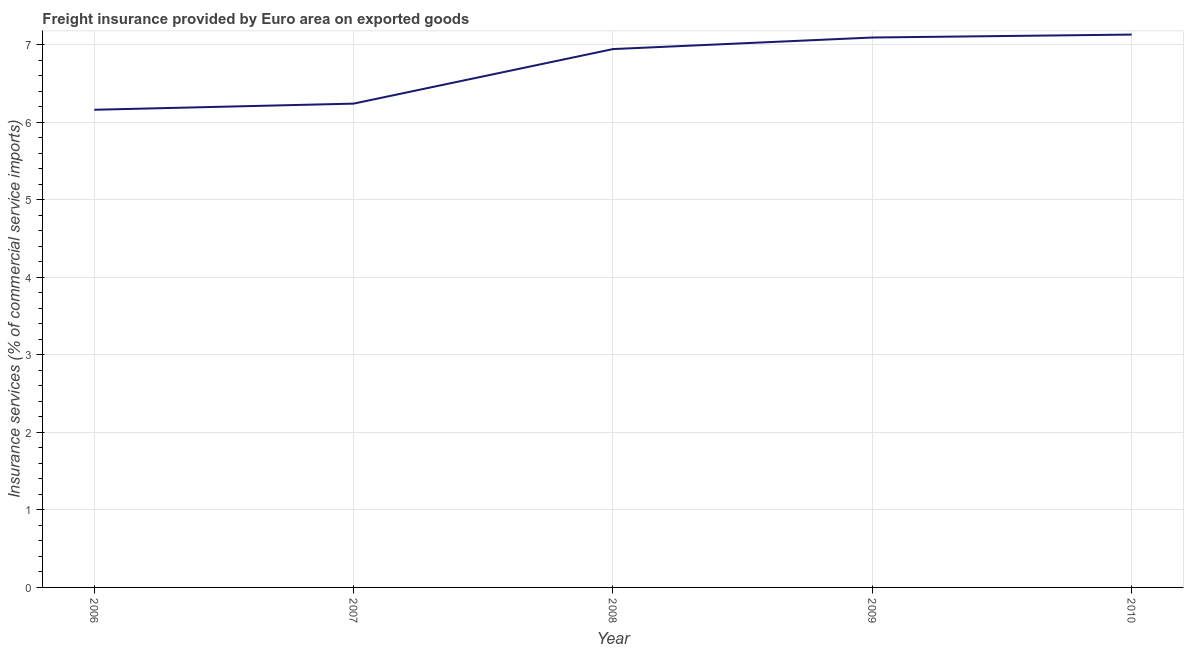What is the freight insurance in 2008?
Ensure brevity in your answer.  6.95. Across all years, what is the maximum freight insurance?
Provide a short and direct response. 7.13. Across all years, what is the minimum freight insurance?
Offer a terse response. 6.16. In which year was the freight insurance maximum?
Keep it short and to the point. 2010. In which year was the freight insurance minimum?
Make the answer very short. 2006. What is the sum of the freight insurance?
Offer a very short reply. 33.58. What is the difference between the freight insurance in 2007 and 2008?
Ensure brevity in your answer.  -0.7. What is the average freight insurance per year?
Give a very brief answer. 6.72. What is the median freight insurance?
Your response must be concise. 6.95. In how many years, is the freight insurance greater than 1.4 %?
Keep it short and to the point. 5. What is the ratio of the freight insurance in 2007 to that in 2008?
Offer a very short reply. 0.9. Is the freight insurance in 2008 less than that in 2009?
Your answer should be very brief. Yes. Is the difference between the freight insurance in 2009 and 2010 greater than the difference between any two years?
Your answer should be very brief. No. What is the difference between the highest and the second highest freight insurance?
Offer a terse response. 0.04. Is the sum of the freight insurance in 2006 and 2007 greater than the maximum freight insurance across all years?
Provide a succinct answer. Yes. What is the difference between the highest and the lowest freight insurance?
Provide a succinct answer. 0.97. In how many years, is the freight insurance greater than the average freight insurance taken over all years?
Your response must be concise. 3. How many years are there in the graph?
Ensure brevity in your answer.  5. Are the values on the major ticks of Y-axis written in scientific E-notation?
Your answer should be compact. No. Does the graph contain any zero values?
Your answer should be very brief. No. What is the title of the graph?
Offer a terse response. Freight insurance provided by Euro area on exported goods . What is the label or title of the Y-axis?
Make the answer very short. Insurance services (% of commercial service imports). What is the Insurance services (% of commercial service imports) in 2006?
Your answer should be very brief. 6.16. What is the Insurance services (% of commercial service imports) of 2007?
Give a very brief answer. 6.24. What is the Insurance services (% of commercial service imports) of 2008?
Your answer should be very brief. 6.95. What is the Insurance services (% of commercial service imports) of 2009?
Ensure brevity in your answer.  7.1. What is the Insurance services (% of commercial service imports) in 2010?
Your response must be concise. 7.13. What is the difference between the Insurance services (% of commercial service imports) in 2006 and 2007?
Your answer should be compact. -0.08. What is the difference between the Insurance services (% of commercial service imports) in 2006 and 2008?
Offer a terse response. -0.78. What is the difference between the Insurance services (% of commercial service imports) in 2006 and 2009?
Your answer should be compact. -0.93. What is the difference between the Insurance services (% of commercial service imports) in 2006 and 2010?
Keep it short and to the point. -0.97. What is the difference between the Insurance services (% of commercial service imports) in 2007 and 2008?
Your answer should be very brief. -0.7. What is the difference between the Insurance services (% of commercial service imports) in 2007 and 2009?
Keep it short and to the point. -0.85. What is the difference between the Insurance services (% of commercial service imports) in 2007 and 2010?
Provide a succinct answer. -0.89. What is the difference between the Insurance services (% of commercial service imports) in 2008 and 2009?
Your answer should be very brief. -0.15. What is the difference between the Insurance services (% of commercial service imports) in 2008 and 2010?
Offer a terse response. -0.19. What is the difference between the Insurance services (% of commercial service imports) in 2009 and 2010?
Provide a succinct answer. -0.04. What is the ratio of the Insurance services (% of commercial service imports) in 2006 to that in 2008?
Make the answer very short. 0.89. What is the ratio of the Insurance services (% of commercial service imports) in 2006 to that in 2009?
Provide a succinct answer. 0.87. What is the ratio of the Insurance services (% of commercial service imports) in 2006 to that in 2010?
Provide a short and direct response. 0.86. What is the ratio of the Insurance services (% of commercial service imports) in 2007 to that in 2008?
Your response must be concise. 0.9. What is the ratio of the Insurance services (% of commercial service imports) in 2008 to that in 2010?
Your answer should be compact. 0.97. 